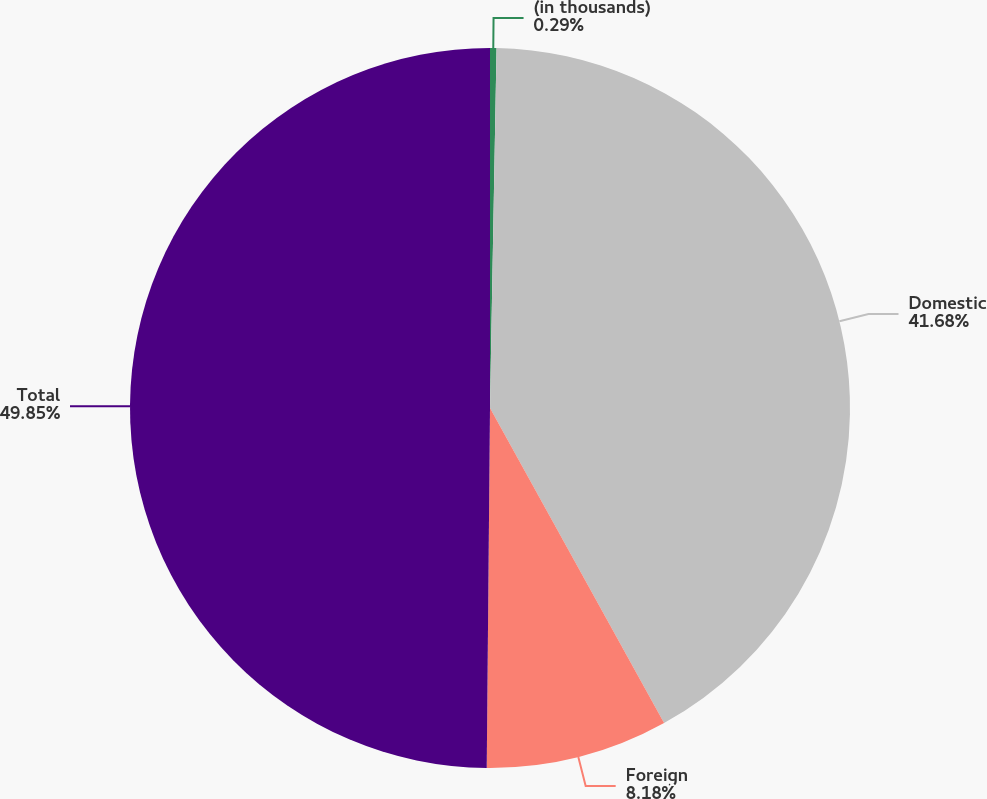Convert chart to OTSL. <chart><loc_0><loc_0><loc_500><loc_500><pie_chart><fcel>(in thousands)<fcel>Domestic<fcel>Foreign<fcel>Total<nl><fcel>0.29%<fcel>41.68%<fcel>8.18%<fcel>49.86%<nl></chart> 